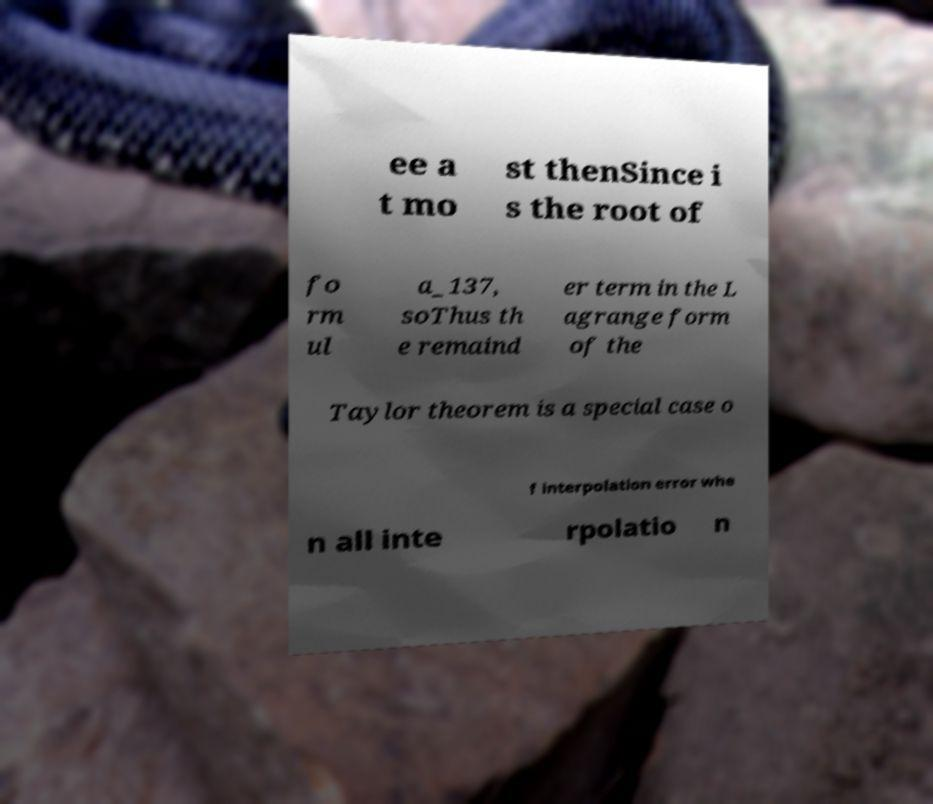Could you extract and type out the text from this image? ee a t mo st thenSince i s the root of fo rm ul a_137, soThus th e remaind er term in the L agrange form of the Taylor theorem is a special case o f interpolation error whe n all inte rpolatio n 